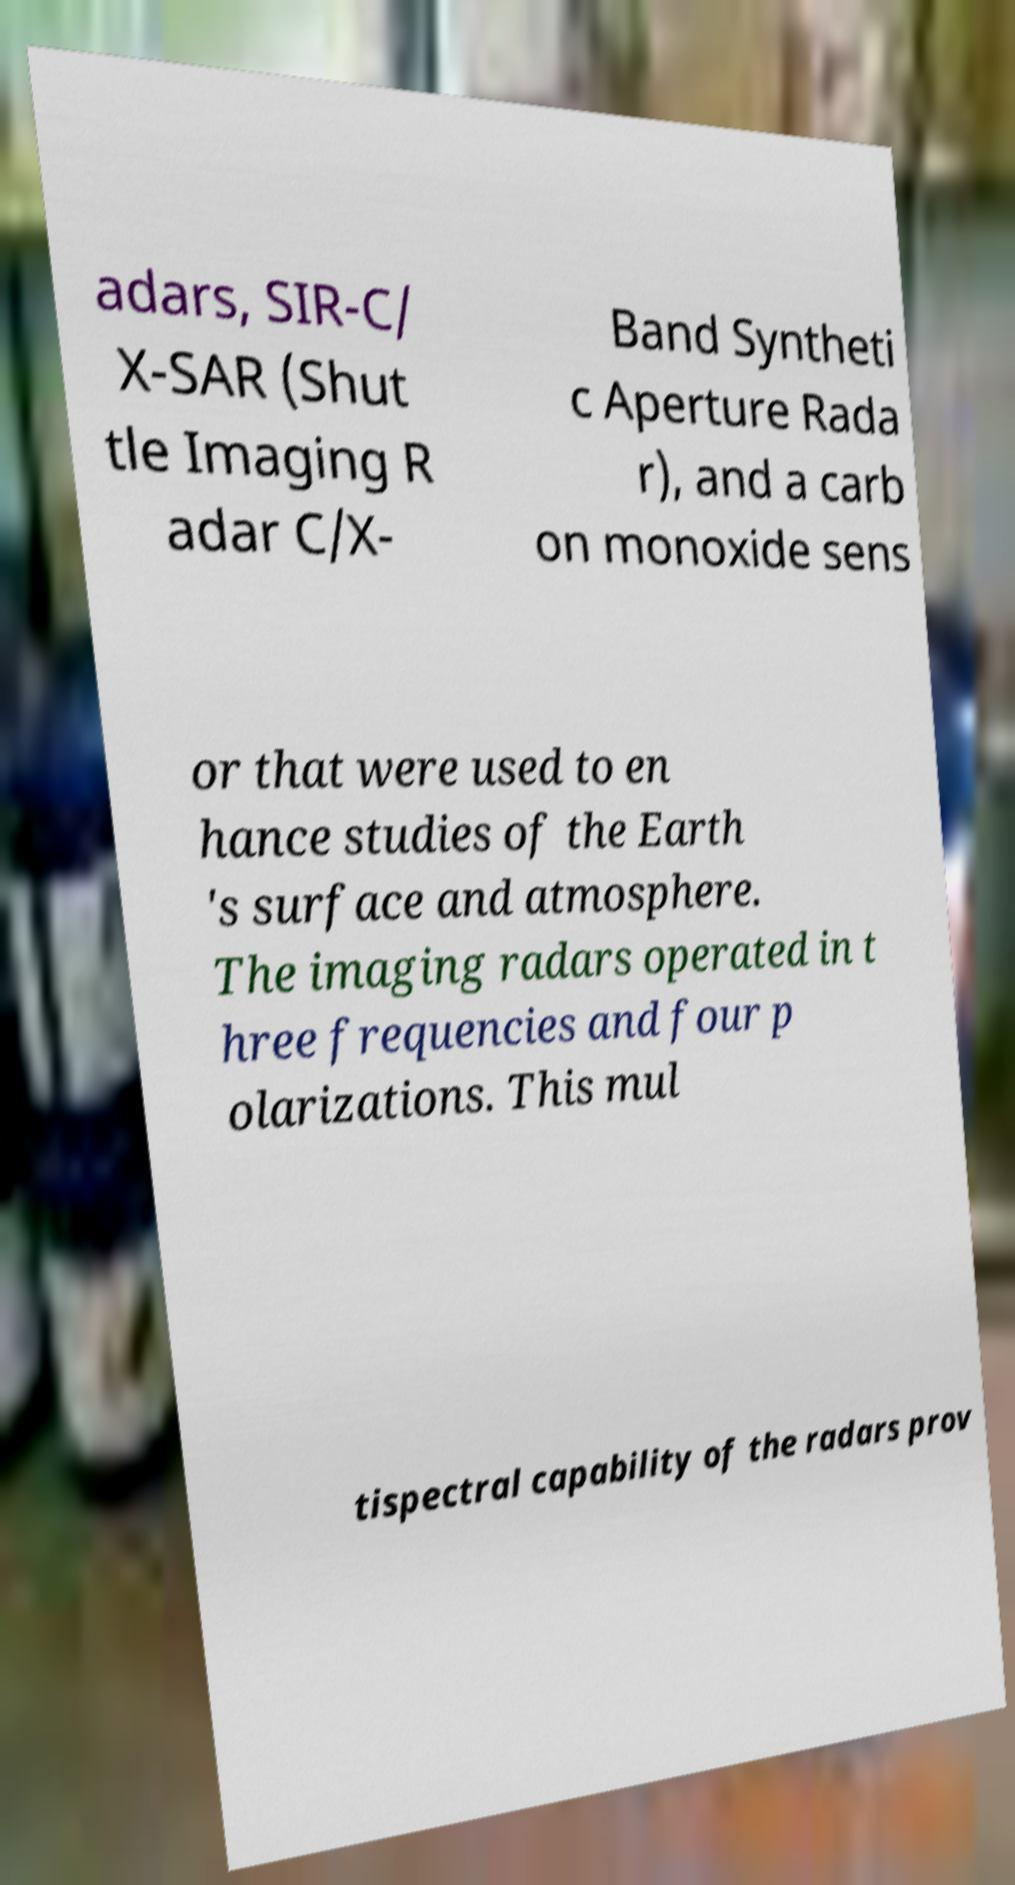Can you read and provide the text displayed in the image?This photo seems to have some interesting text. Can you extract and type it out for me? adars, SIR-C/ X-SAR (Shut tle Imaging R adar C/X- Band Syntheti c Aperture Rada r), and a carb on monoxide sens or that were used to en hance studies of the Earth 's surface and atmosphere. The imaging radars operated in t hree frequencies and four p olarizations. This mul tispectral capability of the radars prov 